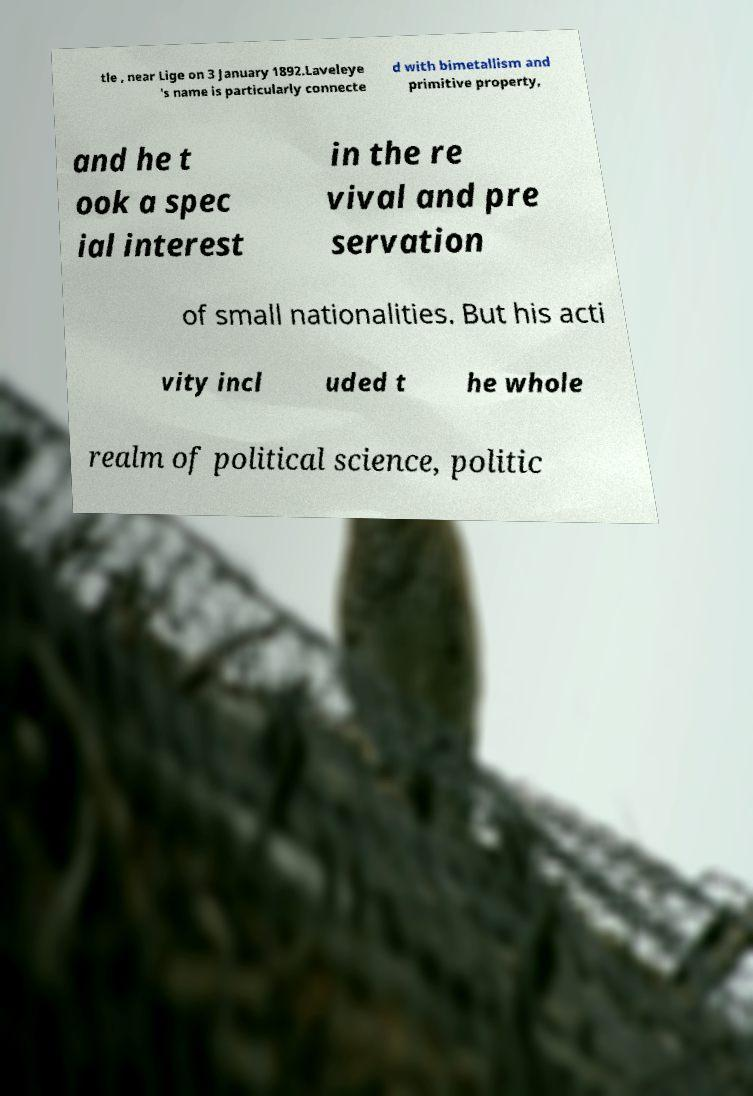For documentation purposes, I need the text within this image transcribed. Could you provide that? tle , near Lige on 3 January 1892.Laveleye 's name is particularly connecte d with bimetallism and primitive property, and he t ook a spec ial interest in the re vival and pre servation of small nationalities. But his acti vity incl uded t he whole realm of political science, politic 